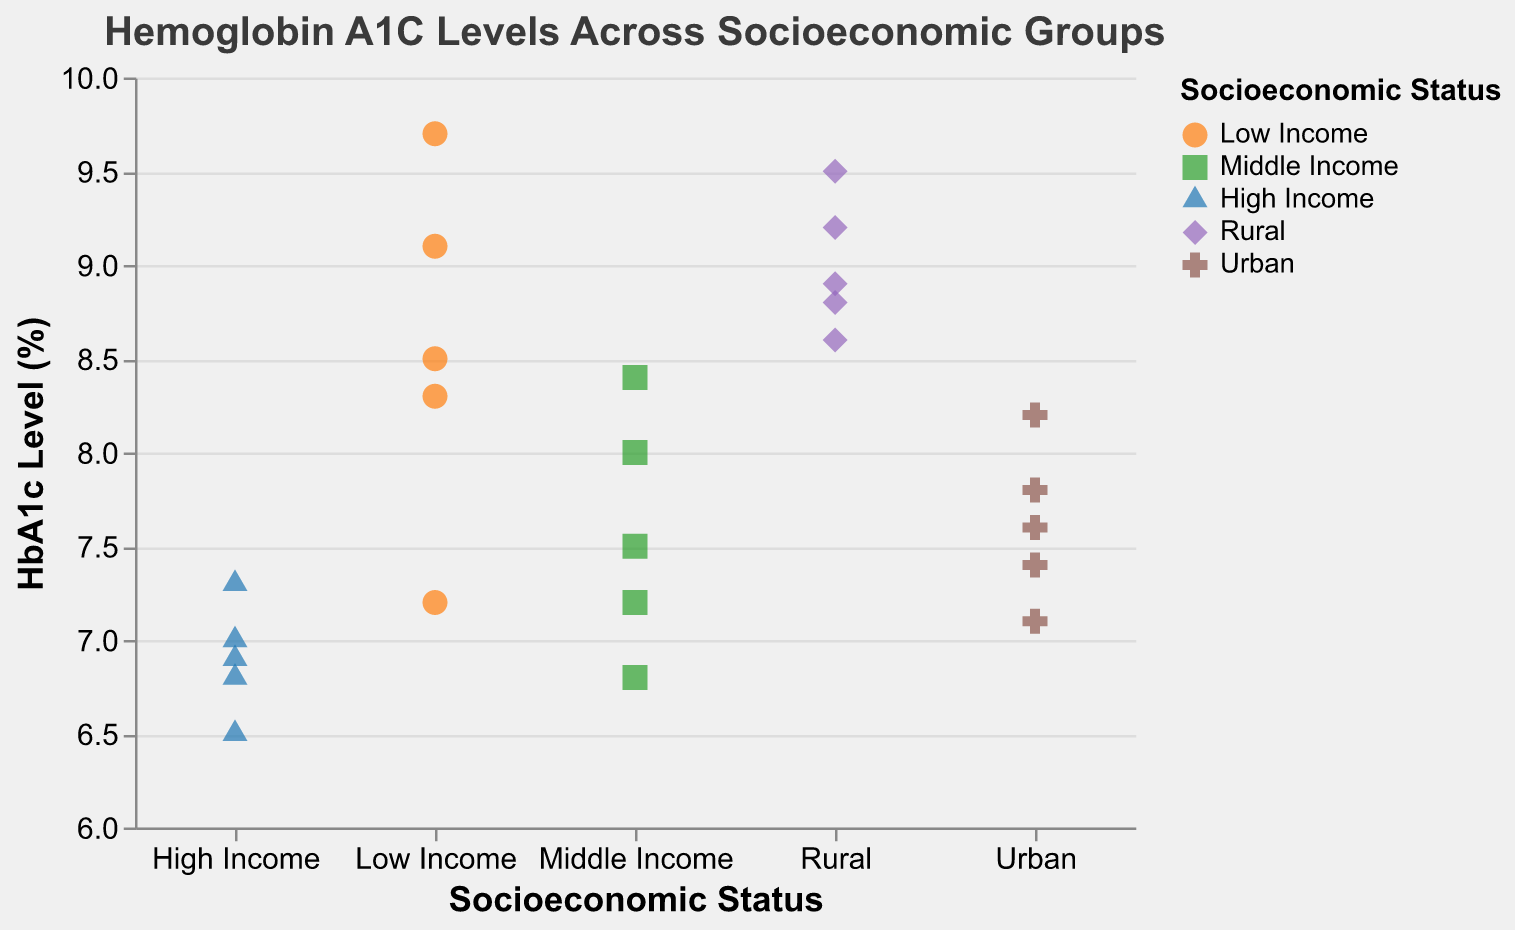What is the title of the plot? The title is displayed at the top of the plot. It reads "Hemoglobin A1C Levels Across Socioeconomic Groups."
Answer: Hemoglobin A1C Levels Across Socioeconomic Groups What is the range of HbA1c levels for the "Low Income" group? By looking at the points corresponding to the "Low Income" group, the lowest value is 7.2, and the highest value is 9.7.
Answer: 7.2 to 9.7 Which socioeconomic group has the lowest HbA1c level? By examining the plot, the "High Income" group has the lowest HbA1c level at 6.5.
Answer: High Income What is the median HbA1c level for the "Rural" group? The HbA1c levels for the "Rural" group are 8.8, 9.2, 8.6, 9.5, and 8.9. Arranging them in ascending order: 8.6, 8.8, 8.9, 9.2, 9.5, the median is the middle value, which is 8.9.
Answer: 8.9 How many data points are there for the "Urban" group? Count the number of points for the "Urban" group. There are five points.
Answer: 5 Compare the highest HbA1c levels between the "Low Income" and "Middle Income" groups. Which one is higher? In the "Low Income" group, the highest HbA1c level is 9.7. In the "Middle Income" group, the highest HbA1c level is 8.4. 9.7 is higher than 8.4.
Answer: Low Income What is the average HbA1c level for the "High Income" group? The HbA1c levels for "High Income" are 6.5, 7.0, 6.8, 7.3, and 6.9. Their sum is 34.5, and dividing by the number of points (5) gives the average: 34.5/5.
Answer: 6.9 Which group has the largest range in HbA1c levels? The range is the difference between the highest and lowest values. For each group:
  - Low Income: 9.7 - 7.2 = 2.5
  - Middle Income: 8.4 - 6.8 = 1.6
  - High Income: 7.3 - 6.5 = 0.8
  - Rural: 9.5 - 8.6 = 0.9
  - Urban: 8.2 - 7.1 = 1.1
The "Low Income" group has the largest range (2.5).
Answer: Low Income Among the "Rural" and "Urban" groups, which has more variability in HbA1c levels? Variability can be observed by looking at the spread of HbA1c levels. The "Rural" group has levels ranging from 8.6 to 9.5 (0.9 range), while the "Urban" group’s levels range from 7.1 to 8.2 (1.1 range). The "Urban" group exhibits slightly more variability.
Answer: Urban 